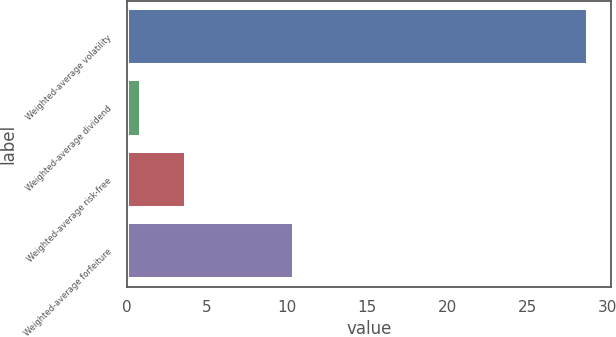<chart> <loc_0><loc_0><loc_500><loc_500><bar_chart><fcel>Weighted-average volatility<fcel>Weighted-average dividend<fcel>Weighted-average risk-free<fcel>Weighted-average forfeiture<nl><fcel>28.79<fcel>0.86<fcel>3.67<fcel>10.43<nl></chart> 